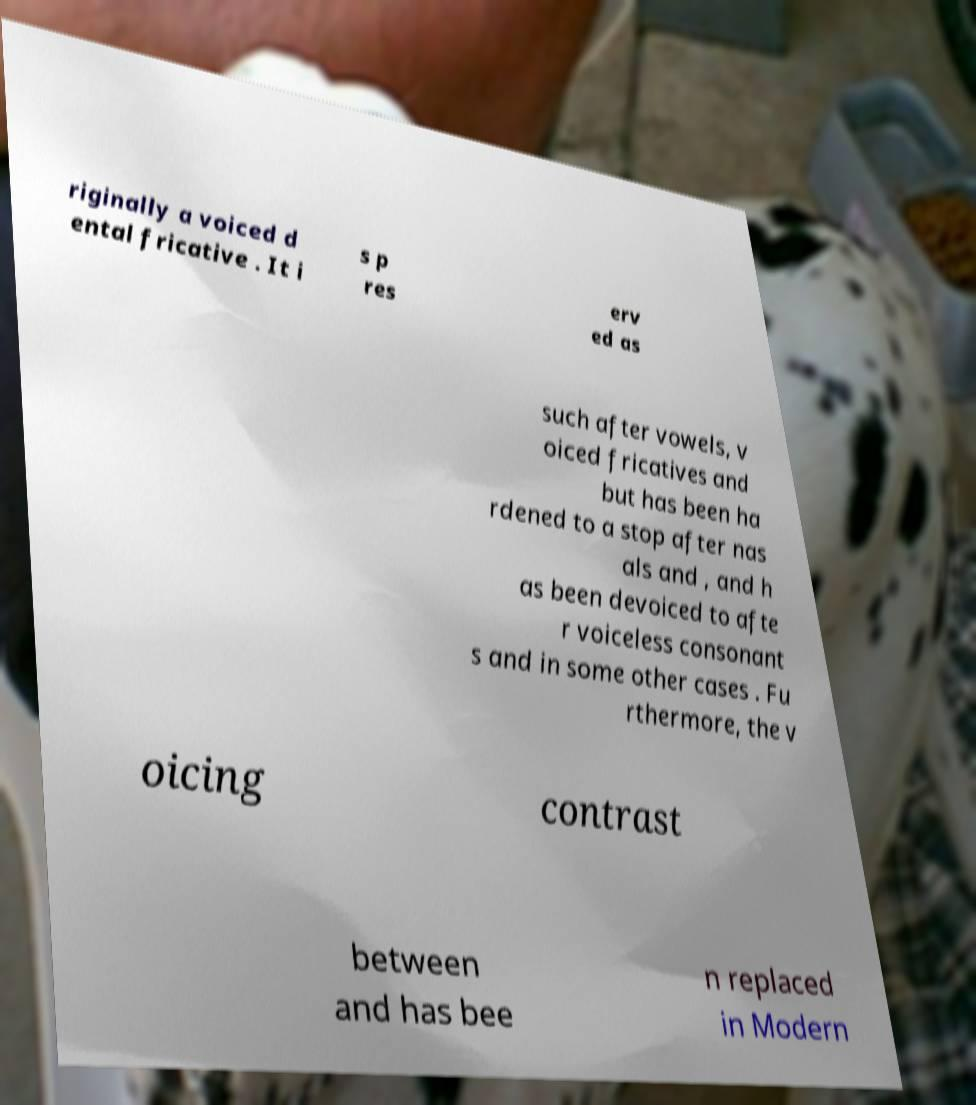Can you accurately transcribe the text from the provided image for me? riginally a voiced d ental fricative . It i s p res erv ed as such after vowels, v oiced fricatives and but has been ha rdened to a stop after nas als and , and h as been devoiced to afte r voiceless consonant s and in some other cases . Fu rthermore, the v oicing contrast between and has bee n replaced in Modern 